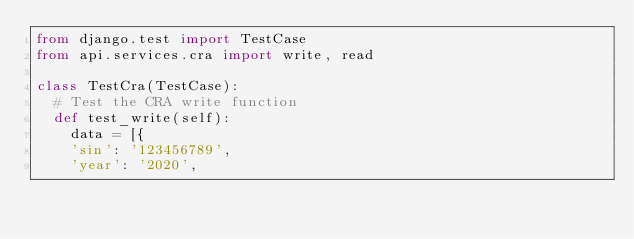<code> <loc_0><loc_0><loc_500><loc_500><_Python_>from django.test import TestCase
from api.services.cra import write, read

class TestCra(TestCase):
  # Test the CRA write function
  def test_write(self):
    data = [{
    'sin': '123456789',
    'year': '2020',</code> 